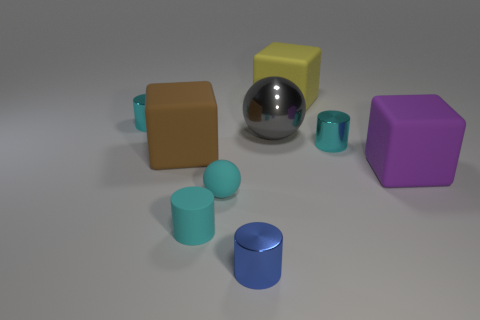There is a tiny shiny thing in front of the purple object; how many metal cylinders are to the right of it?
Offer a terse response. 1. What color is the other small matte thing that is the same shape as the blue object?
Offer a very short reply. Cyan. Are the large purple thing and the small blue cylinder made of the same material?
Your answer should be compact. No. How many cubes are either blue rubber objects or gray things?
Your answer should be very brief. 0. There is a cyan metal thing to the right of the large block that is behind the metal cylinder on the left side of the blue metallic thing; what is its size?
Offer a terse response. Small. There is a brown rubber object that is the same shape as the large yellow matte object; what is its size?
Your answer should be compact. Large. There is a gray shiny sphere; how many gray metallic balls are to the right of it?
Your answer should be compact. 0. Is the color of the ball that is in front of the big ball the same as the metal ball?
Ensure brevity in your answer.  No. What number of purple things are either tiny matte blocks or cubes?
Your answer should be compact. 1. What is the color of the rubber block in front of the brown matte thing on the left side of the yellow thing?
Your answer should be very brief. Purple. 